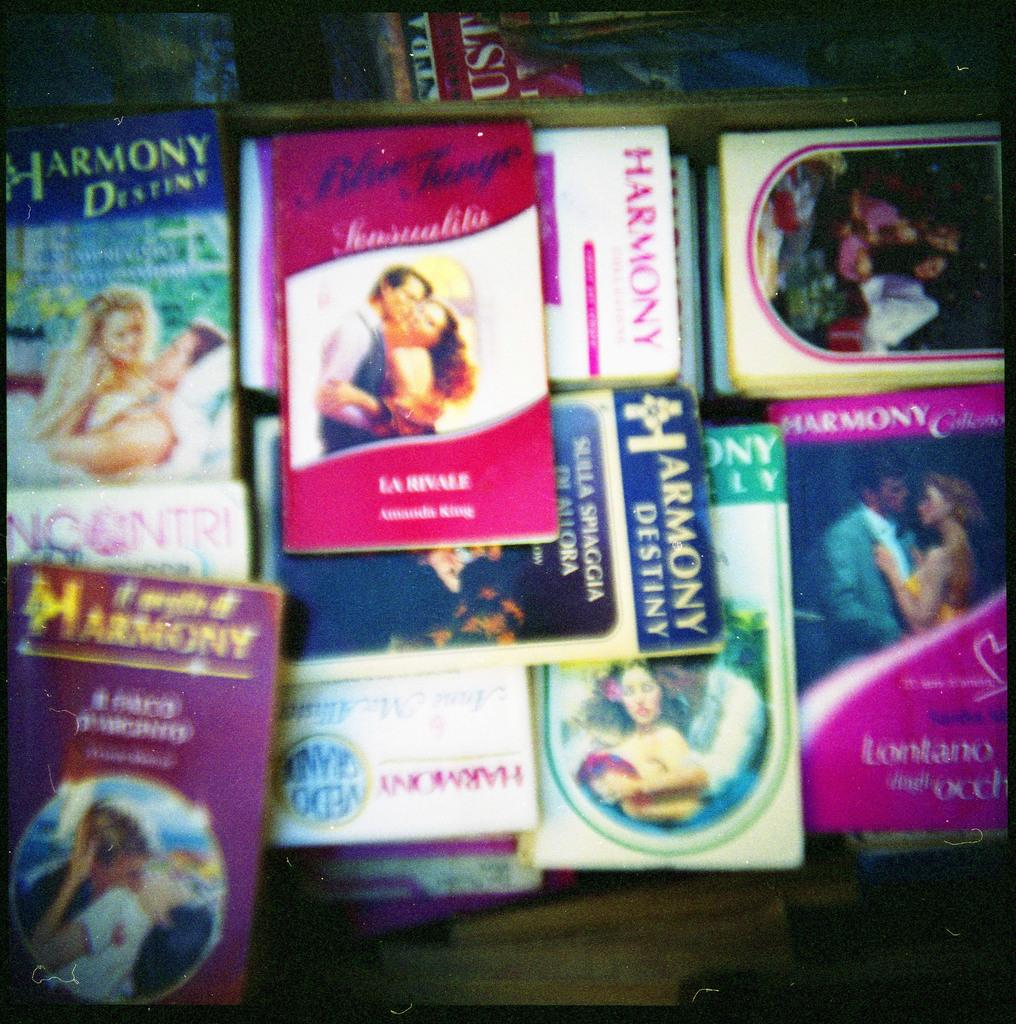<image>
Create a compact narrative representing the image presented. A few books and some of the titles are Harmony Destiny. 